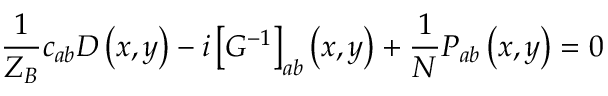<formula> <loc_0><loc_0><loc_500><loc_500>\frac { 1 } { Z _ { B } } c _ { a b } D \left ( x , y \right ) - i \left [ G ^ { - 1 } \right ] _ { a b } \left ( x , y \right ) + \frac { 1 } { N } P _ { a b } \left ( x , y \right ) = 0</formula> 